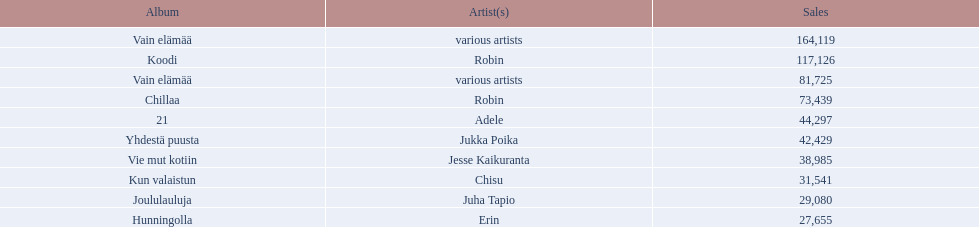Which were the number-one albums of 2012 in finland? Vain elämää, Koodi, Vain elämää, Chillaa, 21, Yhdestä puusta, Vie mut kotiin, Kun valaistun, Joululauluja, Hunningolla. Of those albums, which were by robin? Koodi, Chillaa. Of those albums by robin, which is not chillaa? Koodi. 